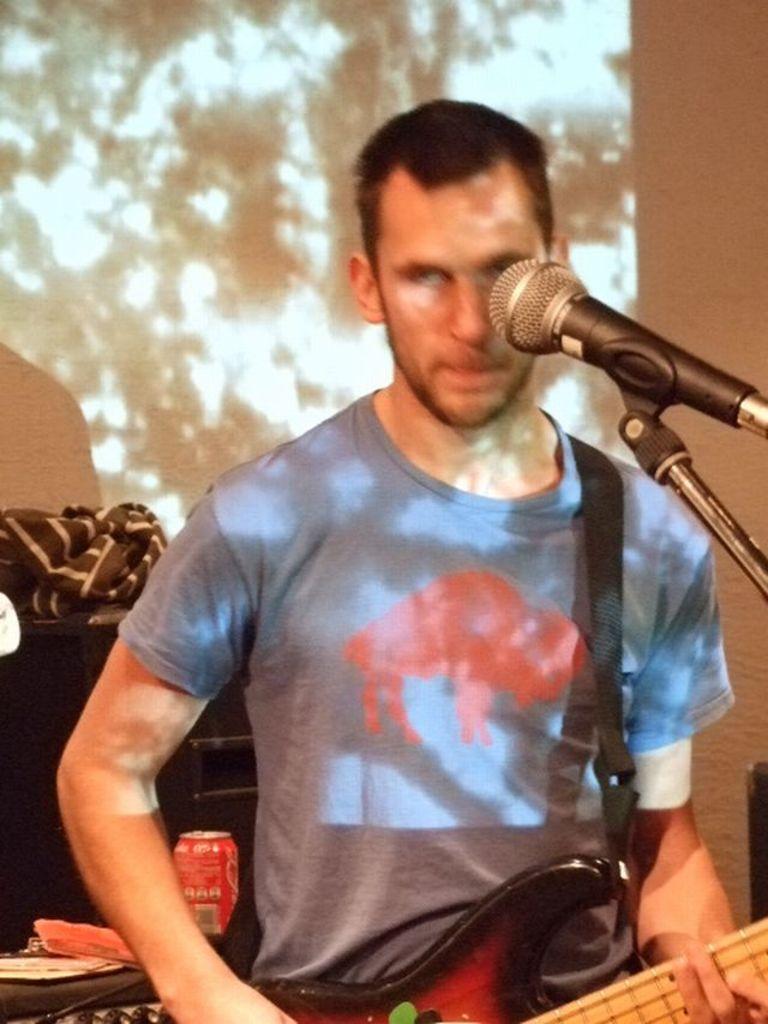How would you summarize this image in a sentence or two? In this picture we can see a man standing in front of mike. He is playing guitar. On the background there is a screen. 